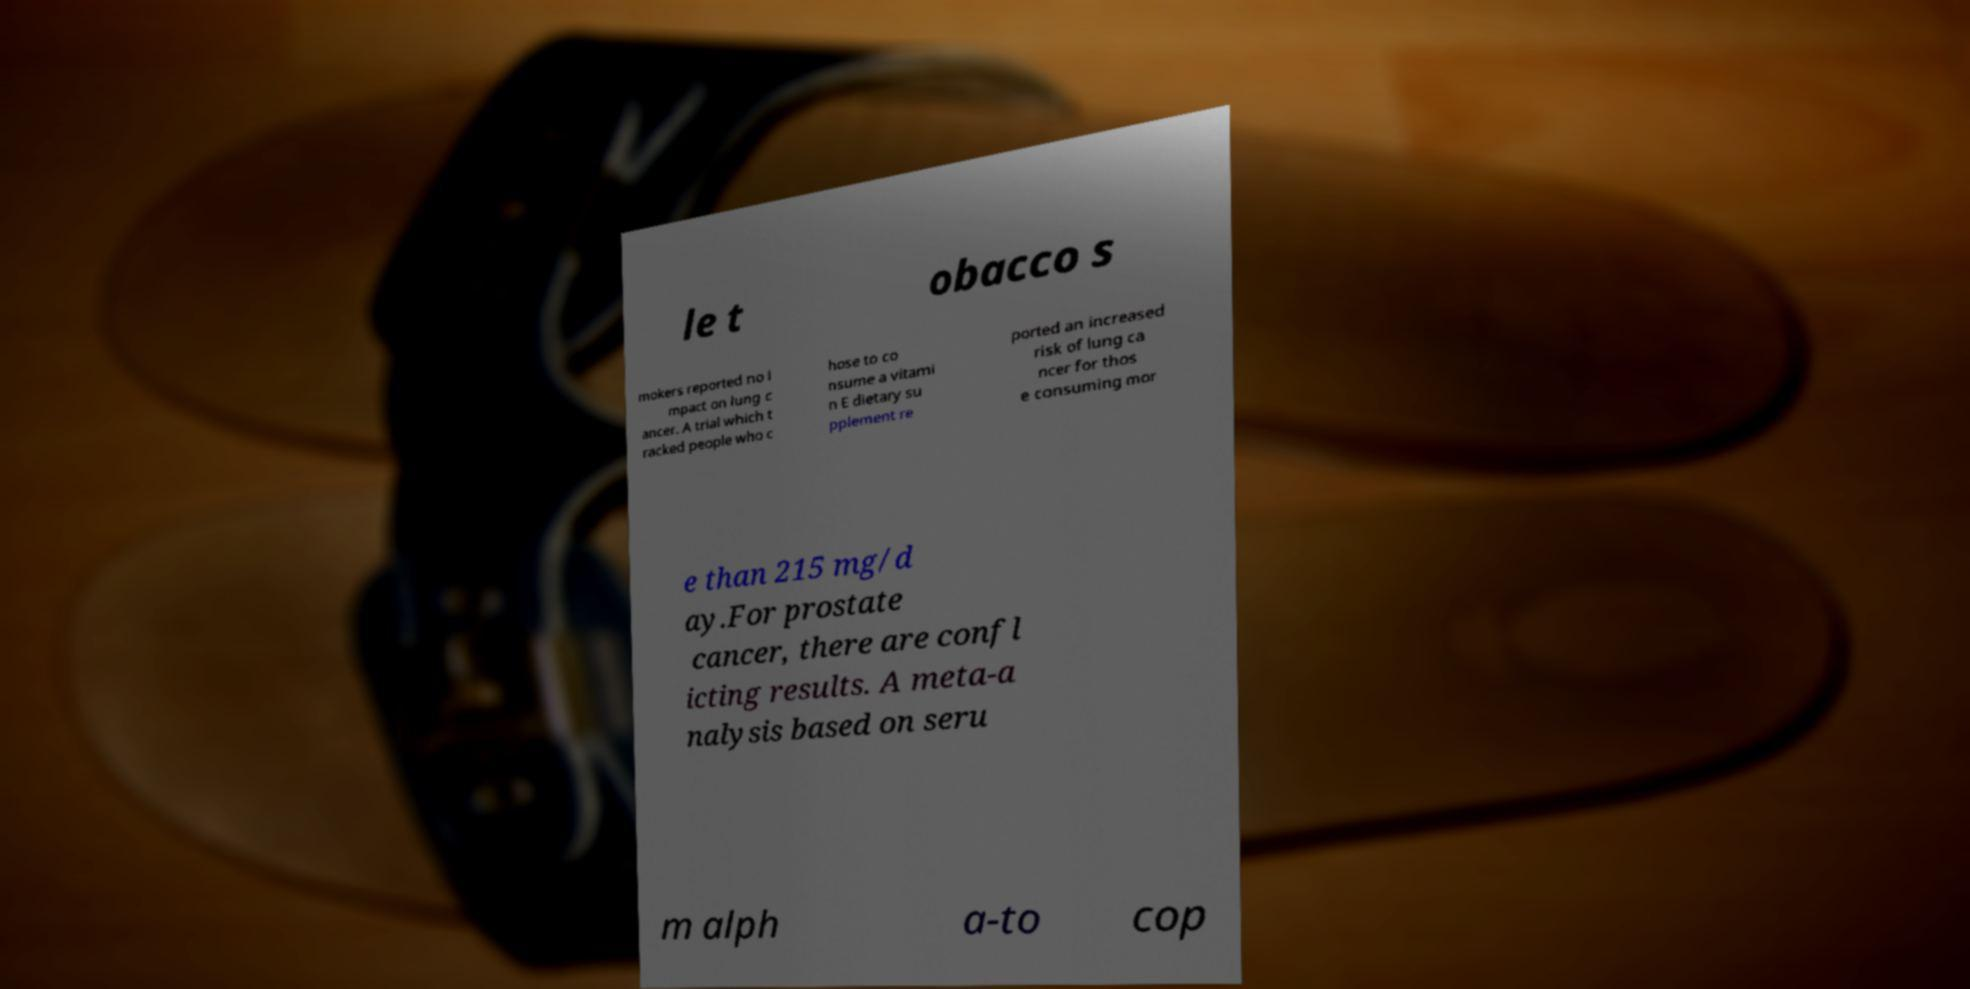Can you accurately transcribe the text from the provided image for me? le t obacco s mokers reported no i mpact on lung c ancer. A trial which t racked people who c hose to co nsume a vitami n E dietary su pplement re ported an increased risk of lung ca ncer for thos e consuming mor e than 215 mg/d ay.For prostate cancer, there are confl icting results. A meta-a nalysis based on seru m alph a-to cop 